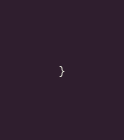<code> <loc_0><loc_0><loc_500><loc_500><_Java_>}
</code> 